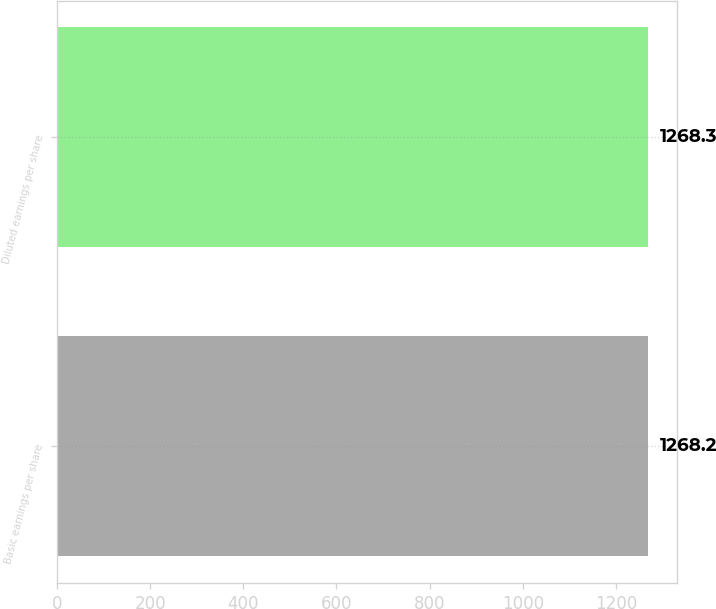Convert chart to OTSL. <chart><loc_0><loc_0><loc_500><loc_500><bar_chart><fcel>Basic earnings per share<fcel>Diluted earnings per share<nl><fcel>1268.2<fcel>1268.3<nl></chart> 